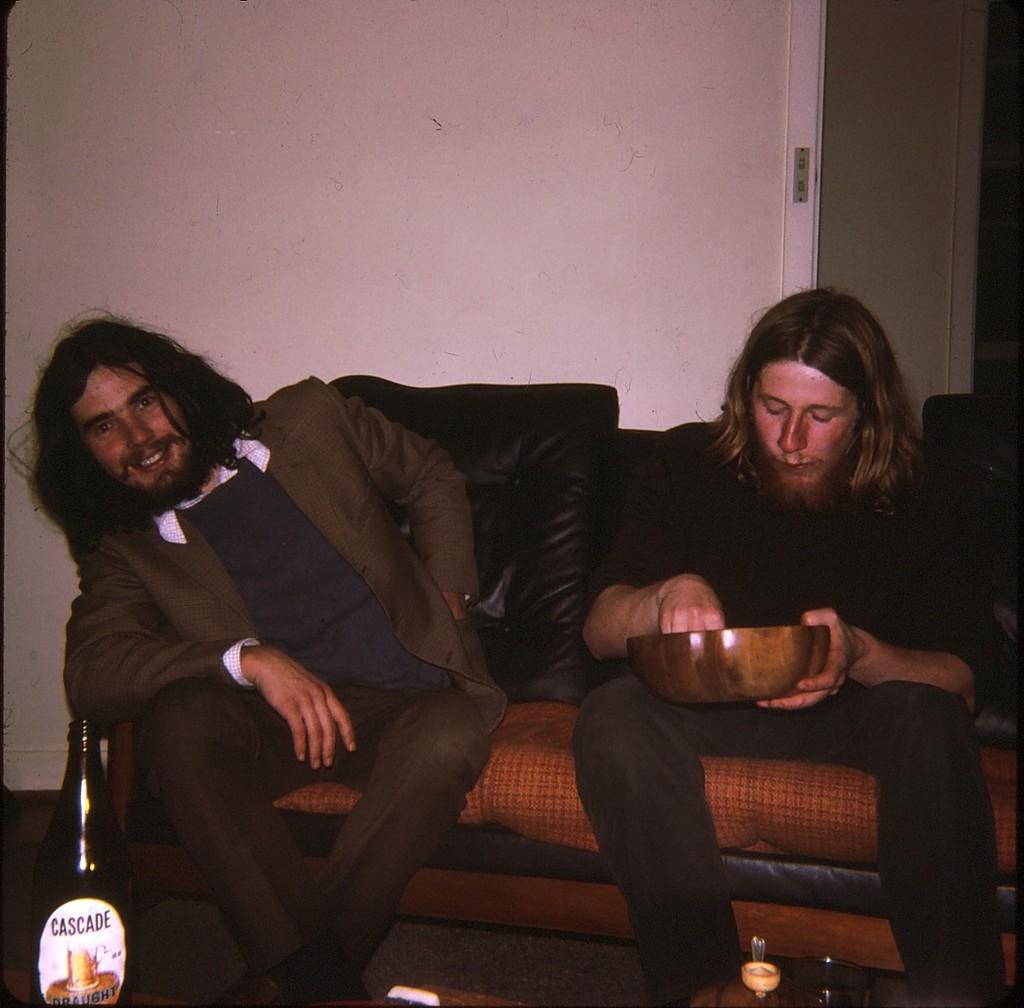Please provide a concise description of this image. In this picture I can see there are two men sitting on the couch and the person at right is eating something in a bowl. There is a bottle, glass in front of them. In the backdrop there is a wall and a door at right side. 